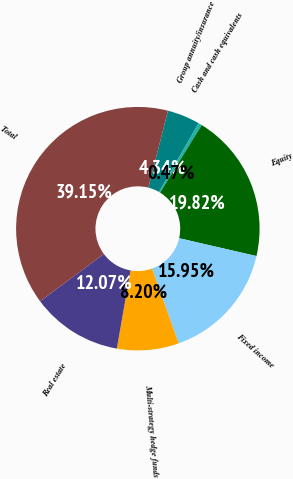Convert chart. <chart><loc_0><loc_0><loc_500><loc_500><pie_chart><fcel>Group annuity/insurance<fcel>Cash and cash equivalents<fcel>Equity<fcel>Fixed income<fcel>Multi-strategy hedge funds<fcel>Real estate<fcel>Total<nl><fcel>4.34%<fcel>0.47%<fcel>19.82%<fcel>15.95%<fcel>8.2%<fcel>12.07%<fcel>39.15%<nl></chart> 